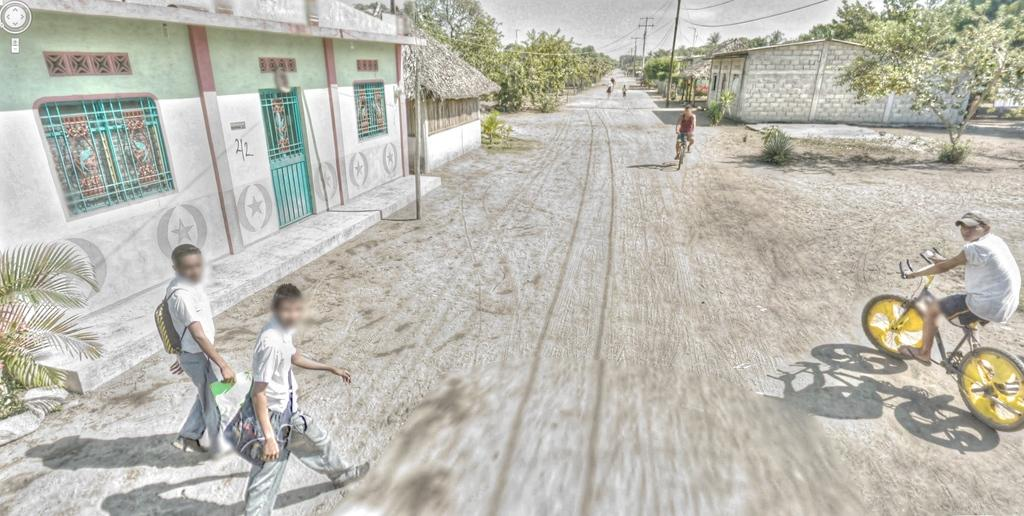What are the two persons in the image doing? The two persons in the image are walking. What are the walking persons carrying? The two persons walking are wearing bags. What are the other two persons in the image doing? The other two persons are riding bicycles. Can you describe the appearance of one of the persons? One person is wearing a cap. What type of setting is visible in the image? There is a road, a house, trees, and the sky visible in the image. What else can be seen in the image? There are poles and wires in the image. How many fingers can be seen waving in the image? There is no indication of anyone waving in the image, so it is not possible to determine the number of fingers. What type of pickle is being used as a prop in the image? There is no pickle present in the image. 